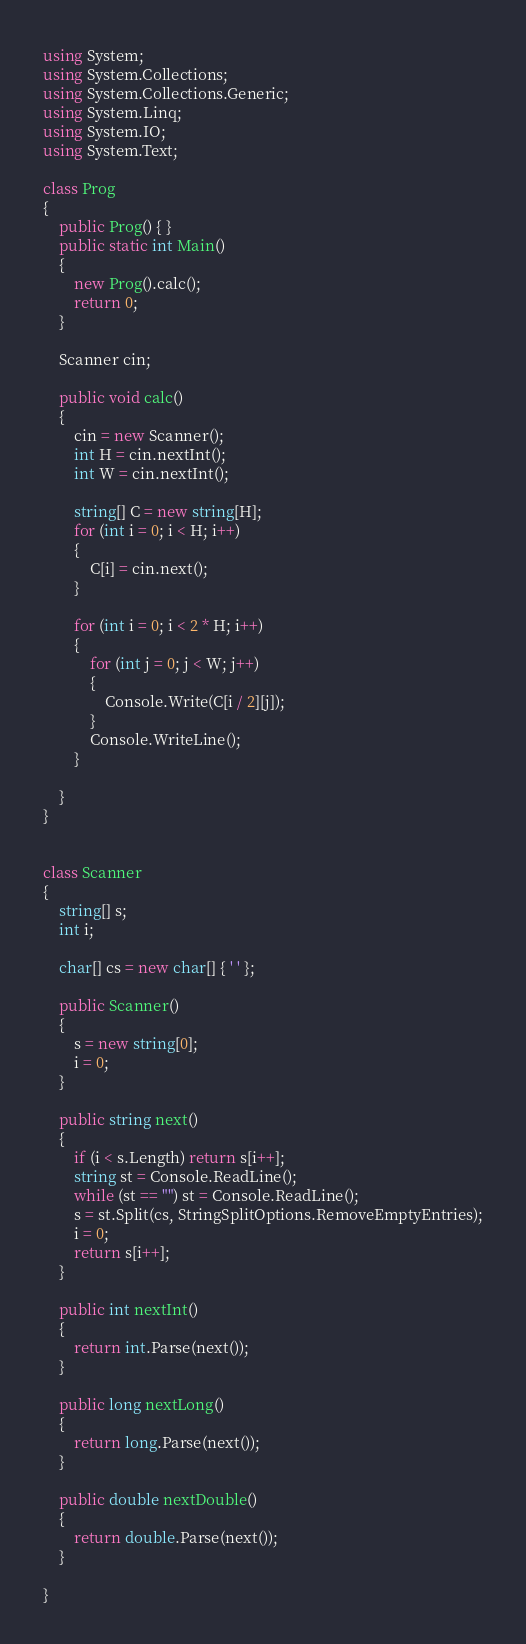<code> <loc_0><loc_0><loc_500><loc_500><_C#_>using System;
using System.Collections;
using System.Collections.Generic;
using System.Linq;
using System.IO;
using System.Text;

class Prog
{
    public Prog() { }
    public static int Main()
    {
        new Prog().calc();
        return 0;
    }

    Scanner cin;

    public void calc()
    {
        cin = new Scanner();
        int H = cin.nextInt();
        int W = cin.nextInt();

        string[] C = new string[H];
        for (int i = 0; i < H; i++)
        {
            C[i] = cin.next();
        }

        for (int i = 0; i < 2 * H; i++)
        {
            for (int j = 0; j < W; j++)
            {
                Console.Write(C[i / 2][j]);
            }
            Console.WriteLine();
        }

    }
}


class Scanner
{
    string[] s;
    int i;

    char[] cs = new char[] { ' ' };

    public Scanner()
    {
        s = new string[0];
        i = 0;
    }

    public string next()
    {
        if (i < s.Length) return s[i++];
        string st = Console.ReadLine();
        while (st == "") st = Console.ReadLine();
        s = st.Split(cs, StringSplitOptions.RemoveEmptyEntries);
        i = 0;
        return s[i++];
    }

    public int nextInt()
    {
        return int.Parse(next());
    }

    public long nextLong()
    {
        return long.Parse(next());
    }

    public double nextDouble()
    {
        return double.Parse(next());
    }

}</code> 